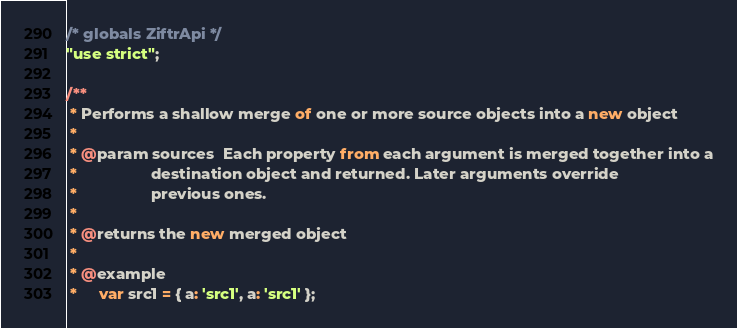Convert code to text. <code><loc_0><loc_0><loc_500><loc_500><_JavaScript_>/* globals ZiftrApi */
"use strict";

/**
 * Performs a shallow merge of one or more source objects into a new object
 *
 * @param sources  Each property from each argument is merged together into a
 *                 destination object and returned. Later arguments override
 *                 previous ones.
 *
 * @returns the new merged object
 *
 * @example
 *     var src1 = { a: 'src1', a: 'src1' };</code> 